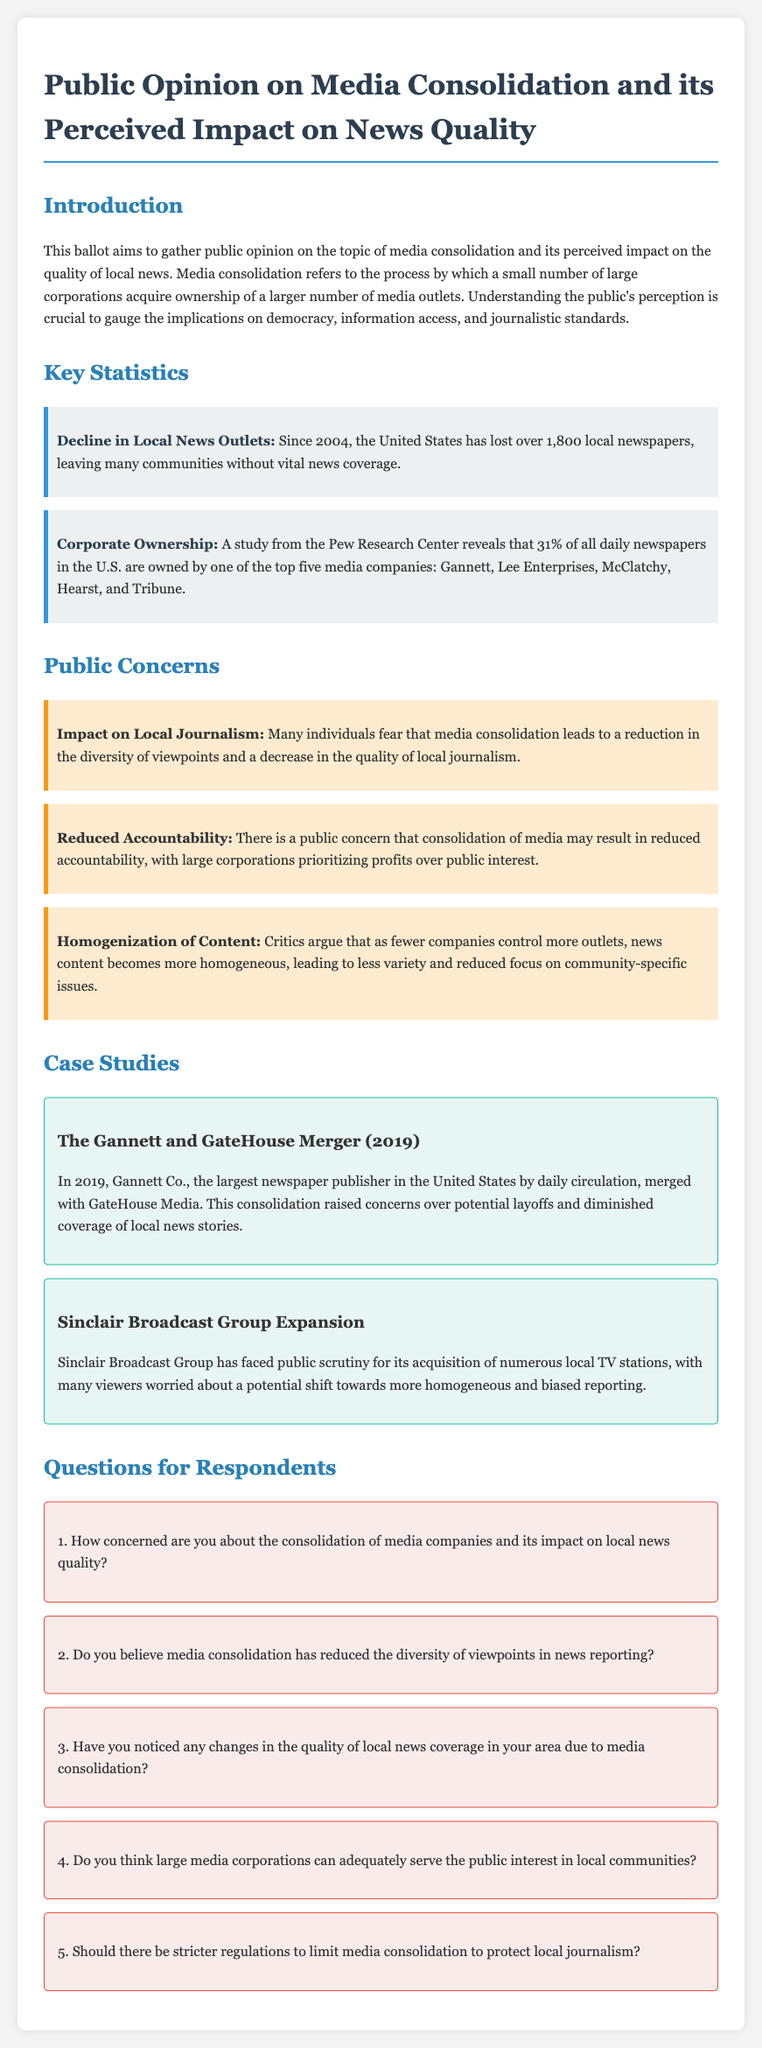What percentage of daily newspapers in the U.S. are owned by the top five media companies? The document states that 31% of all daily newspapers in the U.S. are owned by one of the top five media companies.
Answer: 31% How many local newspapers has the U.S. lost since 2004? According to the document, the U.S. has lost over 1,800 local newspapers since 2004.
Answer: Over 1,800 What is one concern regarding media consolidation mentioned in the document? The document lists concerns such as reduced accountability and homogenization of content regarding media consolidation.
Answer: Reduced accountability What merger is highlighted in the case studies? The case studies feature the Gannett and GateHouse merger in 2019.
Answer: Gannett and GateHouse merger Does the document suggest community-specific issues are being reported less due to media consolidation? The document argues that as fewer companies control more outlets, there is a concern over reduced focus on community-specific issues.
Answer: Yes What is the purpose of the ballot according to the introduction? The purpose of the ballot is to gather public opinion on media consolidation and its perceived impact on the quality of local news.
Answer: Gather public opinion What year did the Gannett and GateHouse merger take place? The merger between Gannett and GateHouse occurred in 2019.
Answer: 2019 What is one characteristic of the Sinclair Broadcast Group mentioned in the case studies? The document describes Sinclair Broadcast Group as facing public scrutiny for its acquisition of numerous local TV stations.
Answer: Facing public scrutiny 